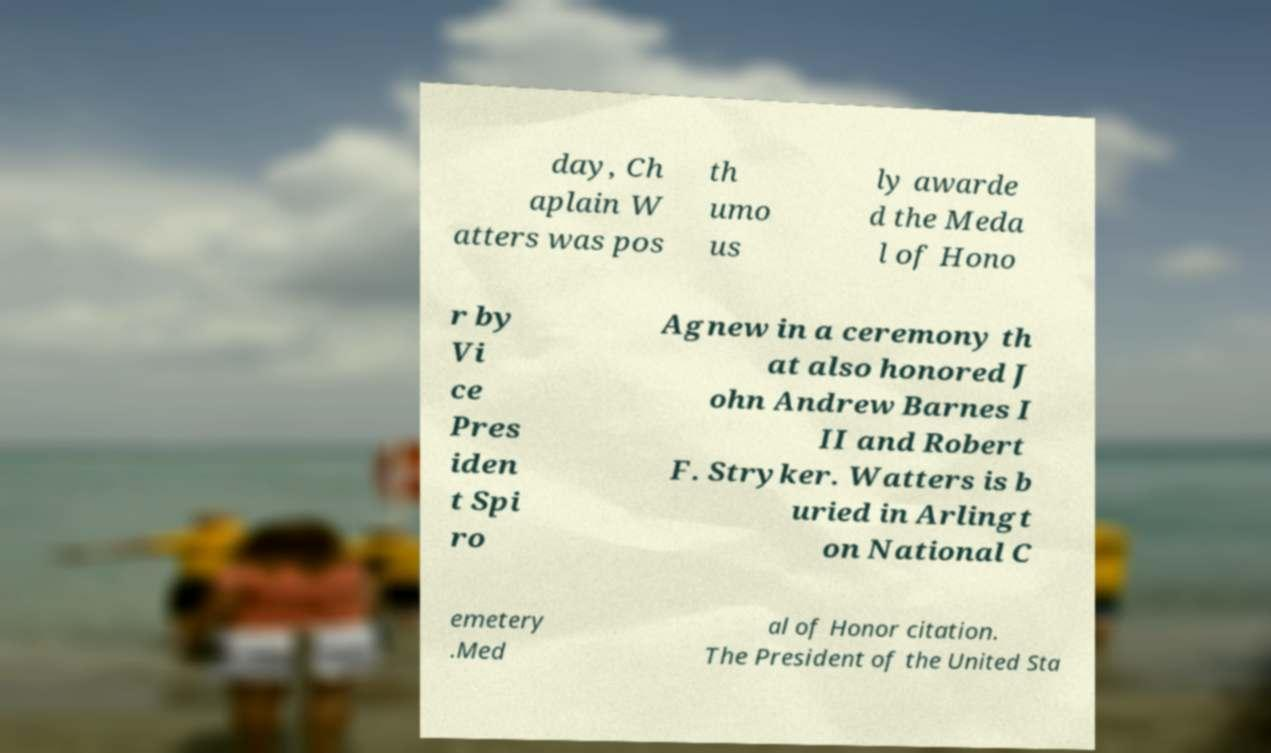For documentation purposes, I need the text within this image transcribed. Could you provide that? day, Ch aplain W atters was pos th umo us ly awarde d the Meda l of Hono r by Vi ce Pres iden t Spi ro Agnew in a ceremony th at also honored J ohn Andrew Barnes I II and Robert F. Stryker. Watters is b uried in Arlingt on National C emetery .Med al of Honor citation. The President of the United Sta 